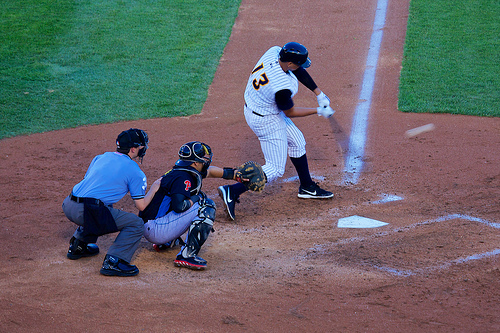Is the player in front of the umpire wearing a cap? No, the player in front of the umpire is not wearing a cap, which is slightly unusual for a player in this setting. 